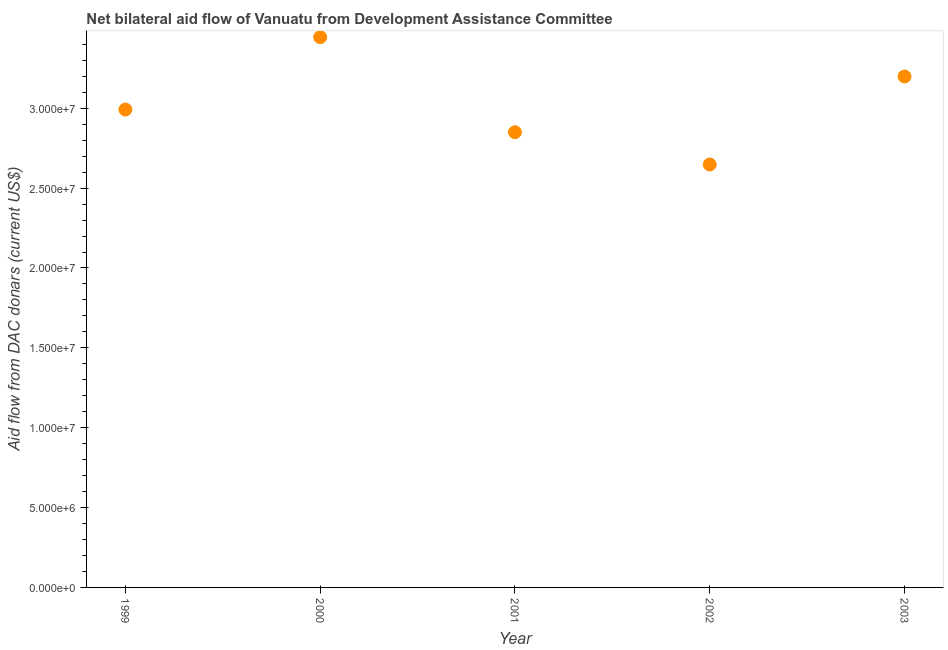What is the net bilateral aid flows from dac donors in 2002?
Offer a terse response. 2.65e+07. Across all years, what is the maximum net bilateral aid flows from dac donors?
Provide a succinct answer. 3.44e+07. Across all years, what is the minimum net bilateral aid flows from dac donors?
Keep it short and to the point. 2.65e+07. What is the sum of the net bilateral aid flows from dac donors?
Provide a succinct answer. 1.51e+08. What is the difference between the net bilateral aid flows from dac donors in 1999 and 2002?
Give a very brief answer. 3.44e+06. What is the average net bilateral aid flows from dac donors per year?
Offer a very short reply. 3.03e+07. What is the median net bilateral aid flows from dac donors?
Offer a terse response. 2.99e+07. In how many years, is the net bilateral aid flows from dac donors greater than 5000000 US$?
Give a very brief answer. 5. Do a majority of the years between 2001 and 2003 (inclusive) have net bilateral aid flows from dac donors greater than 4000000 US$?
Provide a short and direct response. Yes. What is the ratio of the net bilateral aid flows from dac donors in 2001 to that in 2002?
Provide a succinct answer. 1.08. Is the net bilateral aid flows from dac donors in 2000 less than that in 2002?
Make the answer very short. No. Is the difference between the net bilateral aid flows from dac donors in 2000 and 2001 greater than the difference between any two years?
Your answer should be compact. No. What is the difference between the highest and the second highest net bilateral aid flows from dac donors?
Offer a terse response. 2.46e+06. Is the sum of the net bilateral aid flows from dac donors in 2001 and 2003 greater than the maximum net bilateral aid flows from dac donors across all years?
Offer a terse response. Yes. What is the difference between the highest and the lowest net bilateral aid flows from dac donors?
Ensure brevity in your answer.  7.97e+06. How many dotlines are there?
Make the answer very short. 1. How many years are there in the graph?
Ensure brevity in your answer.  5. What is the difference between two consecutive major ticks on the Y-axis?
Your answer should be very brief. 5.00e+06. Are the values on the major ticks of Y-axis written in scientific E-notation?
Make the answer very short. Yes. Does the graph contain any zero values?
Offer a terse response. No. What is the title of the graph?
Provide a succinct answer. Net bilateral aid flow of Vanuatu from Development Assistance Committee. What is the label or title of the Y-axis?
Offer a very short reply. Aid flow from DAC donars (current US$). What is the Aid flow from DAC donars (current US$) in 1999?
Offer a terse response. 2.99e+07. What is the Aid flow from DAC donars (current US$) in 2000?
Provide a succinct answer. 3.44e+07. What is the Aid flow from DAC donars (current US$) in 2001?
Give a very brief answer. 2.85e+07. What is the Aid flow from DAC donars (current US$) in 2002?
Keep it short and to the point. 2.65e+07. What is the Aid flow from DAC donars (current US$) in 2003?
Offer a very short reply. 3.20e+07. What is the difference between the Aid flow from DAC donars (current US$) in 1999 and 2000?
Provide a succinct answer. -4.53e+06. What is the difference between the Aid flow from DAC donars (current US$) in 1999 and 2001?
Provide a succinct answer. 1.42e+06. What is the difference between the Aid flow from DAC donars (current US$) in 1999 and 2002?
Your answer should be very brief. 3.44e+06. What is the difference between the Aid flow from DAC donars (current US$) in 1999 and 2003?
Ensure brevity in your answer.  -2.07e+06. What is the difference between the Aid flow from DAC donars (current US$) in 2000 and 2001?
Offer a very short reply. 5.95e+06. What is the difference between the Aid flow from DAC donars (current US$) in 2000 and 2002?
Make the answer very short. 7.97e+06. What is the difference between the Aid flow from DAC donars (current US$) in 2000 and 2003?
Your response must be concise. 2.46e+06. What is the difference between the Aid flow from DAC donars (current US$) in 2001 and 2002?
Offer a very short reply. 2.02e+06. What is the difference between the Aid flow from DAC donars (current US$) in 2001 and 2003?
Provide a succinct answer. -3.49e+06. What is the difference between the Aid flow from DAC donars (current US$) in 2002 and 2003?
Your answer should be compact. -5.51e+06. What is the ratio of the Aid flow from DAC donars (current US$) in 1999 to that in 2000?
Your answer should be compact. 0.87. What is the ratio of the Aid flow from DAC donars (current US$) in 1999 to that in 2002?
Ensure brevity in your answer.  1.13. What is the ratio of the Aid flow from DAC donars (current US$) in 1999 to that in 2003?
Keep it short and to the point. 0.94. What is the ratio of the Aid flow from DAC donars (current US$) in 2000 to that in 2001?
Your answer should be compact. 1.21. What is the ratio of the Aid flow from DAC donars (current US$) in 2000 to that in 2002?
Offer a terse response. 1.3. What is the ratio of the Aid flow from DAC donars (current US$) in 2000 to that in 2003?
Provide a short and direct response. 1.08. What is the ratio of the Aid flow from DAC donars (current US$) in 2001 to that in 2002?
Your answer should be compact. 1.08. What is the ratio of the Aid flow from DAC donars (current US$) in 2001 to that in 2003?
Your answer should be very brief. 0.89. What is the ratio of the Aid flow from DAC donars (current US$) in 2002 to that in 2003?
Your answer should be very brief. 0.83. 